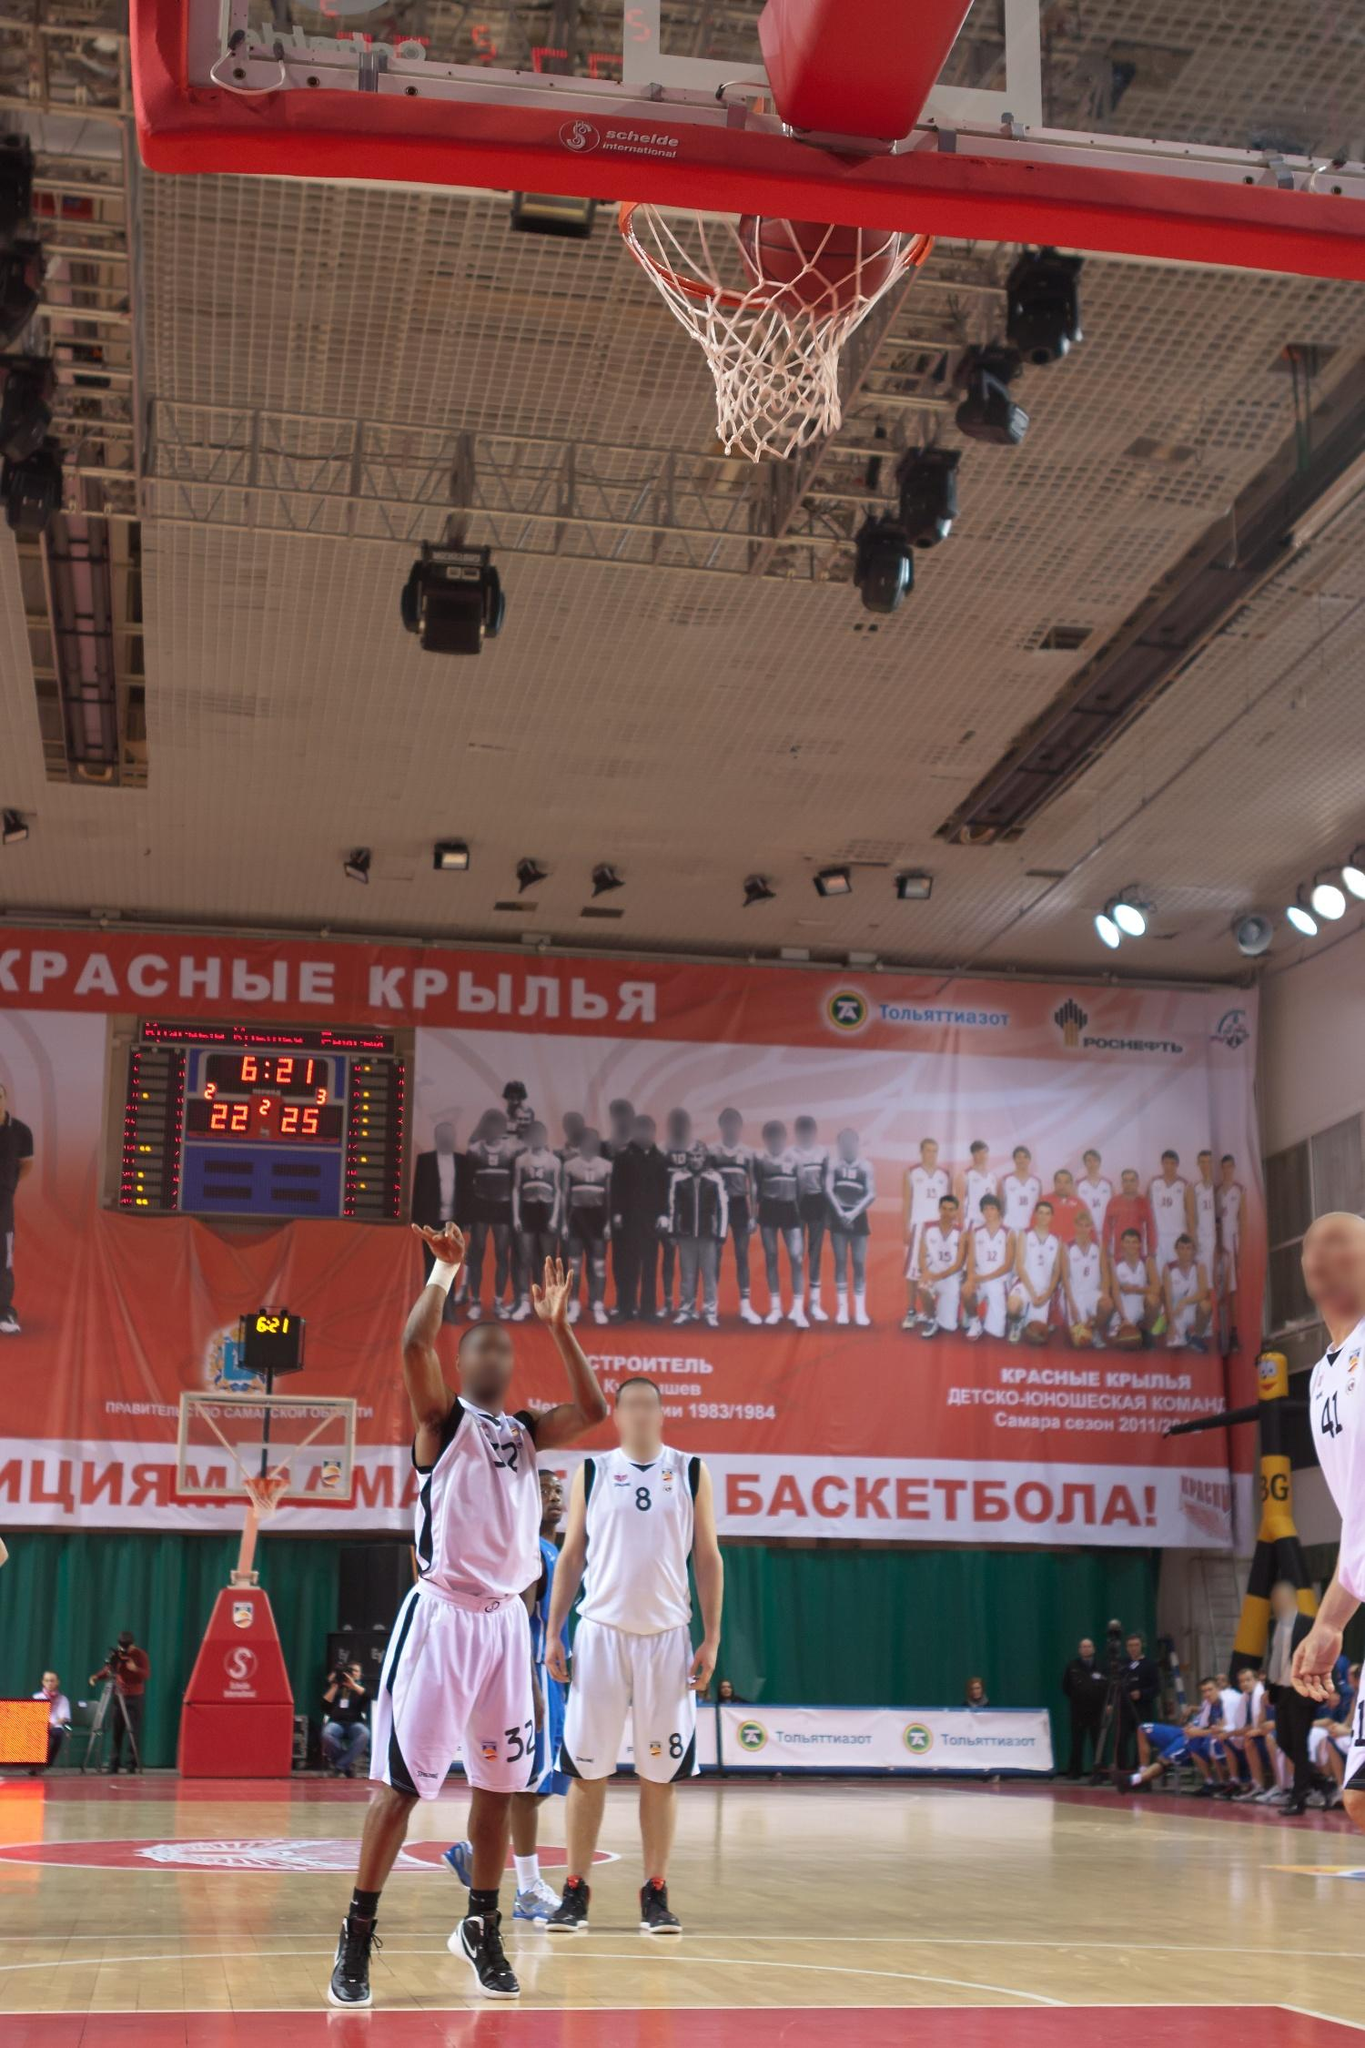What do you think is going on in this snapshot? The image captures a dynamic moment in a basketball game. The court is bustling with energy as players from both teams intensely engage in the action. A key moment is unfolding: a player in a white jersey is leaping into the air, focusing intently on making a crucial shot. He is poised and ready, with the basketball securely in his hands, looking at the hoop with fierce determination. Contrasting this, a player in a blue jersey is also airborne, actively reaching out in an attempt to block the shot, showcasing a high level of competition and athleticism.

The other players are positioned around the court, their eyes locked onto the central action, contributing to the charged atmosphere of the game. The scoreboard in the background displays the time and score, showing 6 minutes and 21 seconds remaining in the second quarter with a close score of 22-25, but it’s not clear which team is leading.

Adding to the environment, a large banner with the words "Красные крылья," translating to "Red Wings," hints at the team’s name or the venue. The image represents a thrilling and pivotal moment in the game, with every player laser-focused on their roles, embodying the spirit of competitive sports. 